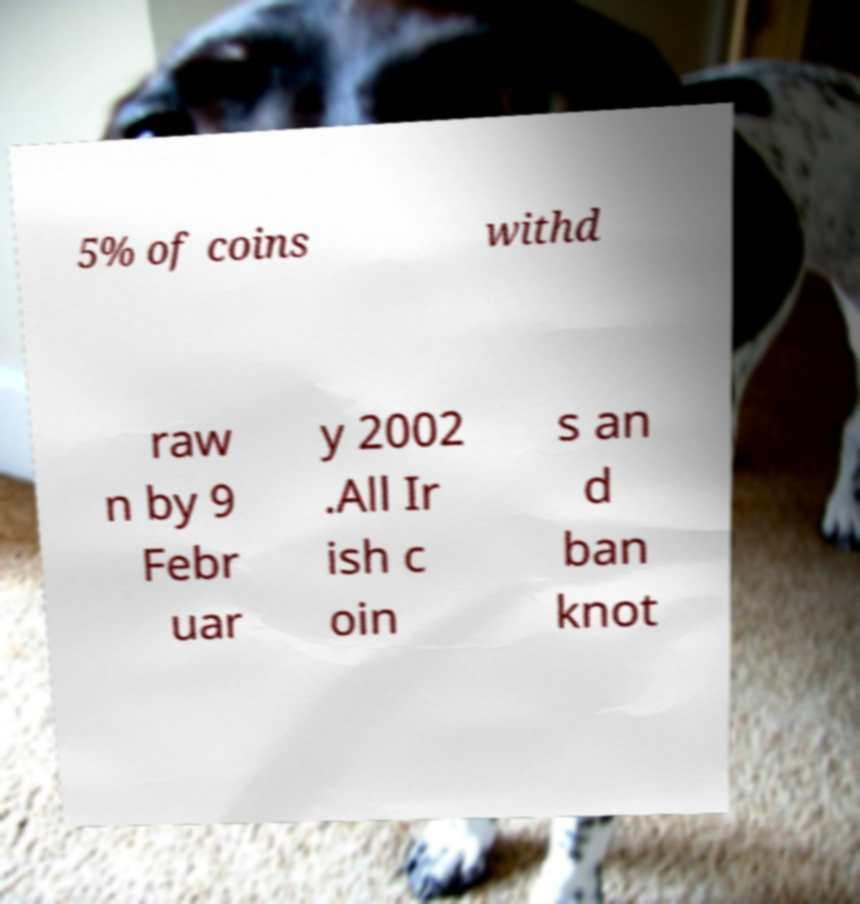Could you assist in decoding the text presented in this image and type it out clearly? 5% of coins withd raw n by 9 Febr uar y 2002 .All Ir ish c oin s an d ban knot 